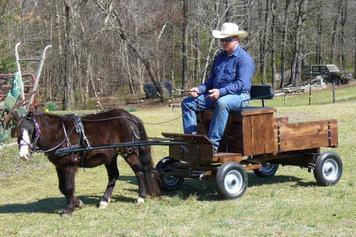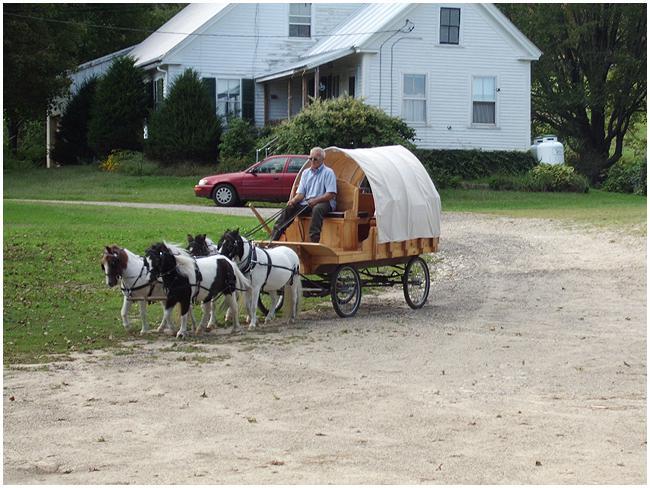The first image is the image on the left, the second image is the image on the right. Assess this claim about the two images: "In at least one image there is a single man with a hat on a cart being pulled by at least one mini horse.". Correct or not? Answer yes or no. Yes. The first image is the image on the left, the second image is the image on the right. Considering the images on both sides, is "A man in a hat is riding on the seat of a leftward-facing four-wheeled wagon pulled by one small black pony." valid? Answer yes or no. Yes. 